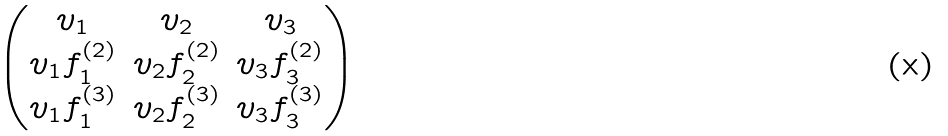<formula> <loc_0><loc_0><loc_500><loc_500>\begin{pmatrix} v _ { 1 } & v _ { 2 } & v _ { 3 } \\ v _ { 1 } f ^ { ( 2 ) } _ { 1 } & v _ { 2 } f ^ { ( 2 ) } _ { 2 } & v _ { 3 } f ^ { ( 2 ) } _ { 3 } \\ v _ { 1 } f ^ { ( 3 ) } _ { 1 } & v _ { 2 } f ^ { ( 3 ) } _ { 2 } & v _ { 3 } f ^ { ( 3 ) } _ { 3 } \end{pmatrix}</formula> 